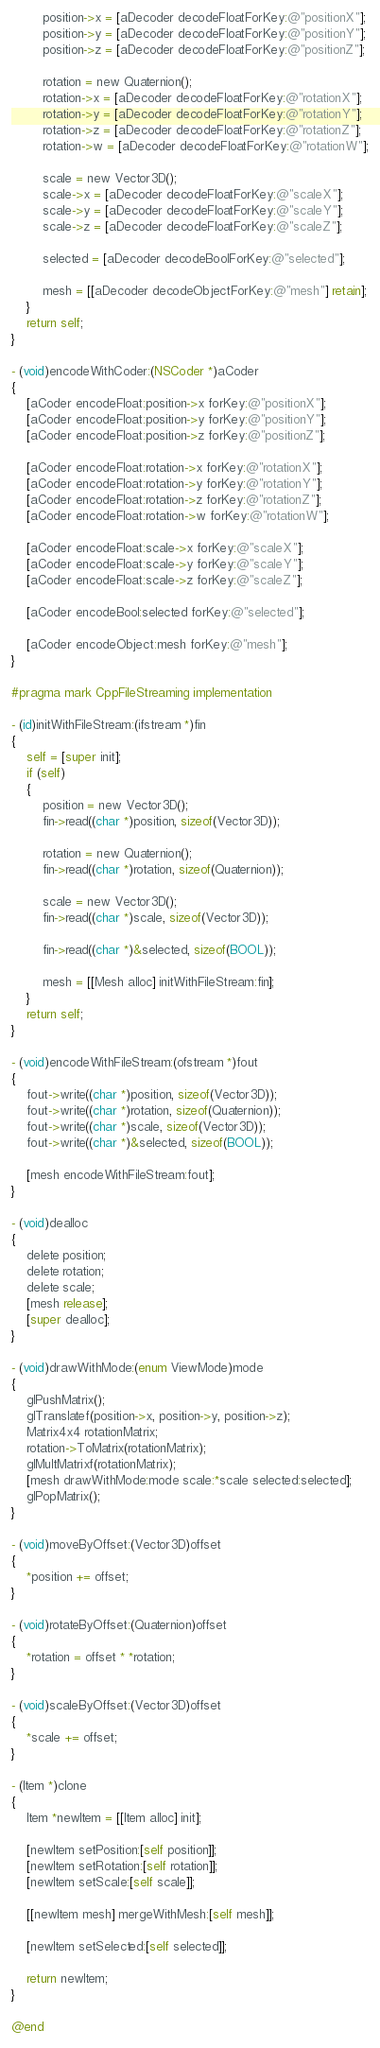Convert code to text. <code><loc_0><loc_0><loc_500><loc_500><_ObjectiveC_>		position->x = [aDecoder decodeFloatForKey:@"positionX"];
		position->y = [aDecoder decodeFloatForKey:@"positionY"];
		position->z = [aDecoder decodeFloatForKey:@"positionZ"];
		
		rotation = new Quaternion();
		rotation->x = [aDecoder decodeFloatForKey:@"rotationX"];
		rotation->y = [aDecoder decodeFloatForKey:@"rotationY"];
		rotation->z = [aDecoder decodeFloatForKey:@"rotationZ"];
		rotation->w = [aDecoder decodeFloatForKey:@"rotationW"];
		
		scale = new Vector3D();
		scale->x = [aDecoder decodeFloatForKey:@"scaleX"];
		scale->y = [aDecoder decodeFloatForKey:@"scaleY"];
		scale->z = [aDecoder decodeFloatForKey:@"scaleZ"];
		
		selected = [aDecoder decodeBoolForKey:@"selected"];
		
		mesh = [[aDecoder decodeObjectForKey:@"mesh"] retain];
	}
	return self;
}

- (void)encodeWithCoder:(NSCoder *)aCoder
{	
	[aCoder encodeFloat:position->x forKey:@"positionX"];
	[aCoder encodeFloat:position->y forKey:@"positionY"];
	[aCoder encodeFloat:position->z forKey:@"positionZ"];
	
	[aCoder encodeFloat:rotation->x forKey:@"rotationX"];
	[aCoder encodeFloat:rotation->y forKey:@"rotationY"];
	[aCoder encodeFloat:rotation->z forKey:@"rotationZ"];
	[aCoder encodeFloat:rotation->w forKey:@"rotationW"];
	
	[aCoder encodeFloat:scale->x forKey:@"scaleX"];
	[aCoder encodeFloat:scale->y forKey:@"scaleY"];
	[aCoder encodeFloat:scale->z forKey:@"scaleZ"];
	
	[aCoder encodeBool:selected forKey:@"selected"];
	
	[aCoder encodeObject:mesh forKey:@"mesh"];
}

#pragma mark CppFileStreaming implementation

- (id)initWithFileStream:(ifstream *)fin
{
	self = [super init];
	if (self)
	{
		position = new Vector3D();
		fin->read((char *)position, sizeof(Vector3D));
		
		rotation = new Quaternion();
		fin->read((char *)rotation, sizeof(Quaternion));
		
		scale = new Vector3D();
		fin->read((char *)scale, sizeof(Vector3D));
		
		fin->read((char *)&selected, sizeof(BOOL));
		
		mesh = [[Mesh alloc] initWithFileStream:fin];
	}
	return self;
}

- (void)encodeWithFileStream:(ofstream *)fout
{
	fout->write((char *)position, sizeof(Vector3D));
	fout->write((char *)rotation, sizeof(Quaternion));
	fout->write((char *)scale, sizeof(Vector3D));
	fout->write((char *)&selected, sizeof(BOOL));
	
	[mesh encodeWithFileStream:fout];
}

- (void)dealloc
{
	delete position;
	delete rotation;
	delete scale;
	[mesh release];
	[super dealloc];
}

- (void)drawWithMode:(enum ViewMode)mode
{
	glPushMatrix();
	glTranslatef(position->x, position->y, position->z);
	Matrix4x4 rotationMatrix;
	rotation->ToMatrix(rotationMatrix);
	glMultMatrixf(rotationMatrix);
	[mesh drawWithMode:mode scale:*scale selected:selected];
	glPopMatrix();
}

- (void)moveByOffset:(Vector3D)offset
{
	*position += offset;
}

- (void)rotateByOffset:(Quaternion)offset
{
	*rotation = offset * *rotation;
}

- (void)scaleByOffset:(Vector3D)offset
{
	*scale += offset;
}

- (Item *)clone
{
	Item *newItem = [[Item alloc] init];

	[newItem setPosition:[self position]];
	[newItem setRotation:[self rotation]];
	[newItem setScale:[self scale]];
	
	[[newItem mesh] mergeWithMesh:[self mesh]];
	
	[newItem setSelected:[self selected]];
	
	return newItem;
}

@end
</code> 